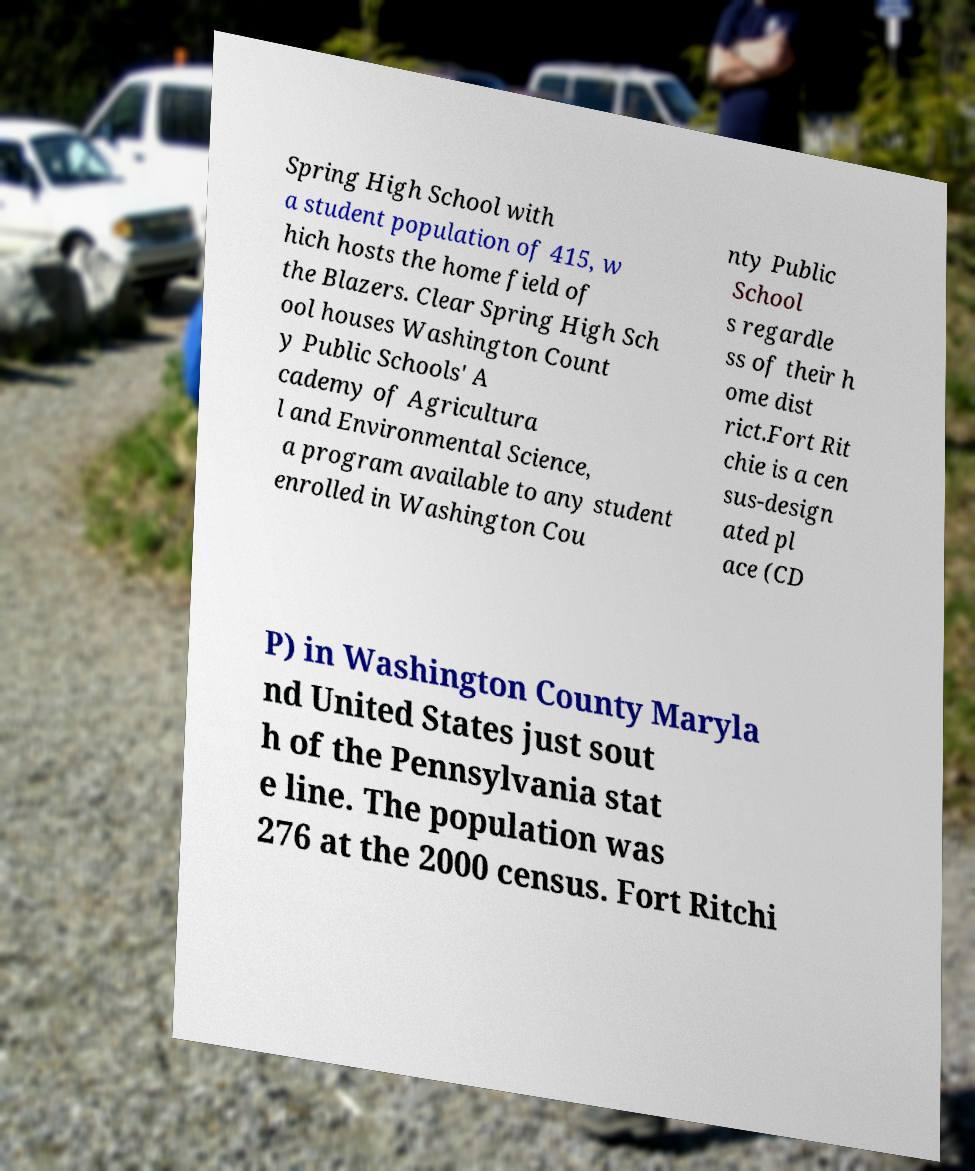Can you accurately transcribe the text from the provided image for me? Spring High School with a student population of 415, w hich hosts the home field of the Blazers. Clear Spring High Sch ool houses Washington Count y Public Schools' A cademy of Agricultura l and Environmental Science, a program available to any student enrolled in Washington Cou nty Public School s regardle ss of their h ome dist rict.Fort Rit chie is a cen sus-design ated pl ace (CD P) in Washington County Maryla nd United States just sout h of the Pennsylvania stat e line. The population was 276 at the 2000 census. Fort Ritchi 